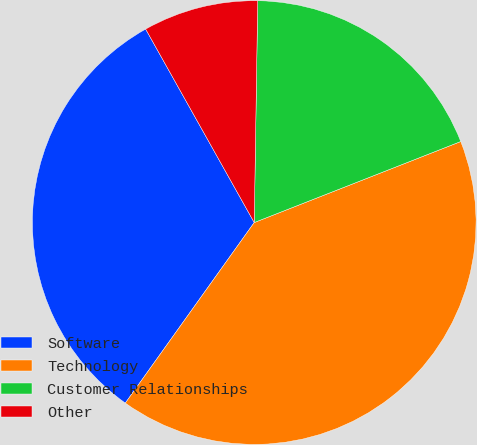Convert chart to OTSL. <chart><loc_0><loc_0><loc_500><loc_500><pie_chart><fcel>Software<fcel>Technology<fcel>Customer Relationships<fcel>Other<nl><fcel>31.99%<fcel>40.82%<fcel>18.8%<fcel>8.39%<nl></chart> 